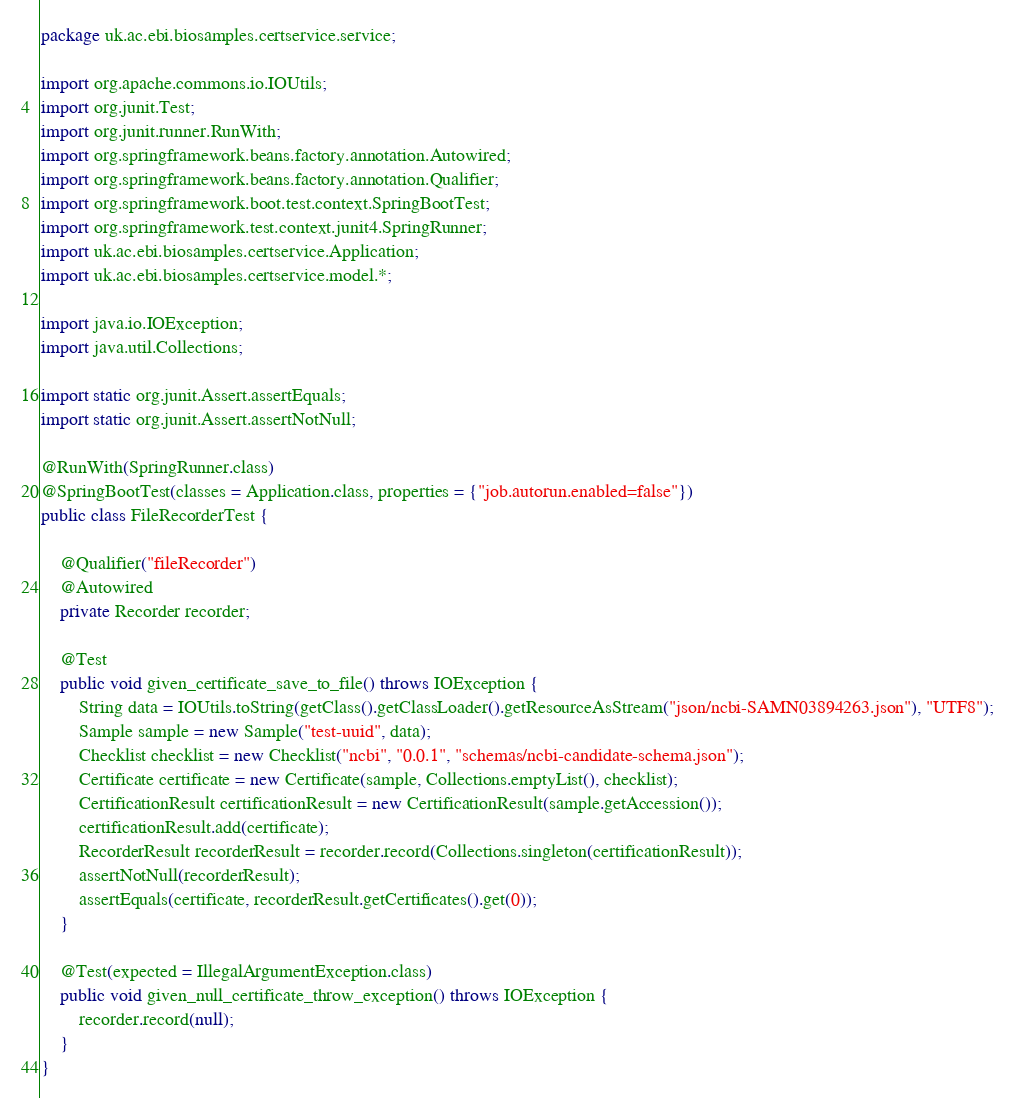Convert code to text. <code><loc_0><loc_0><loc_500><loc_500><_Java_>package uk.ac.ebi.biosamples.certservice.service;

import org.apache.commons.io.IOUtils;
import org.junit.Test;
import org.junit.runner.RunWith;
import org.springframework.beans.factory.annotation.Autowired;
import org.springframework.beans.factory.annotation.Qualifier;
import org.springframework.boot.test.context.SpringBootTest;
import org.springframework.test.context.junit4.SpringRunner;
import uk.ac.ebi.biosamples.certservice.Application;
import uk.ac.ebi.biosamples.certservice.model.*;

import java.io.IOException;
import java.util.Collections;

import static org.junit.Assert.assertEquals;
import static org.junit.Assert.assertNotNull;

@RunWith(SpringRunner.class)
@SpringBootTest(classes = Application.class, properties = {"job.autorun.enabled=false"})
public class FileRecorderTest {

    @Qualifier("fileRecorder")
    @Autowired
    private Recorder recorder;

    @Test
    public void given_certificate_save_to_file() throws IOException {
        String data = IOUtils.toString(getClass().getClassLoader().getResourceAsStream("json/ncbi-SAMN03894263.json"), "UTF8");
        Sample sample = new Sample("test-uuid", data);
        Checklist checklist = new Checklist("ncbi", "0.0.1", "schemas/ncbi-candidate-schema.json");
        Certificate certificate = new Certificate(sample, Collections.emptyList(), checklist);
        CertificationResult certificationResult = new CertificationResult(sample.getAccession());
        certificationResult.add(certificate);
        RecorderResult recorderResult = recorder.record(Collections.singleton(certificationResult));
        assertNotNull(recorderResult);
        assertEquals(certificate, recorderResult.getCertificates().get(0));
    }

    @Test(expected = IllegalArgumentException.class)
    public void given_null_certificate_throw_exception() throws IOException {
        recorder.record(null);
    }
}
</code> 